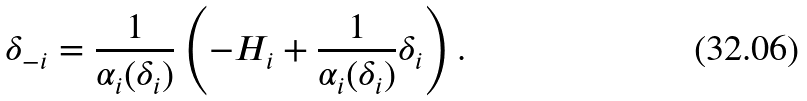Convert formula to latex. <formula><loc_0><loc_0><loc_500><loc_500>\delta _ { - i } = \frac { 1 } { \alpha _ { i } ( \delta _ { i } ) } \left ( - H _ { i } + \frac { 1 } { \alpha _ { i } ( \delta _ { i } ) } \delta _ { i } \right ) .</formula> 